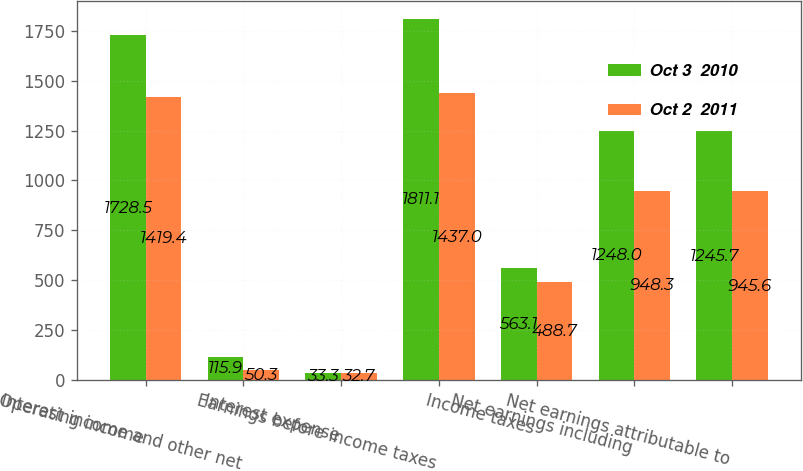Convert chart. <chart><loc_0><loc_0><loc_500><loc_500><stacked_bar_chart><ecel><fcel>Operating income<fcel>Interest income and other net<fcel>Interest expense<fcel>Earnings before income taxes<fcel>Income taxes<fcel>Net earnings including<fcel>Net earnings attributable to<nl><fcel>Oct 3  2010<fcel>1728.5<fcel>115.9<fcel>33.3<fcel>1811.1<fcel>563.1<fcel>1248<fcel>1245.7<nl><fcel>Oct 2  2011<fcel>1419.4<fcel>50.3<fcel>32.7<fcel>1437<fcel>488.7<fcel>948.3<fcel>945.6<nl></chart> 